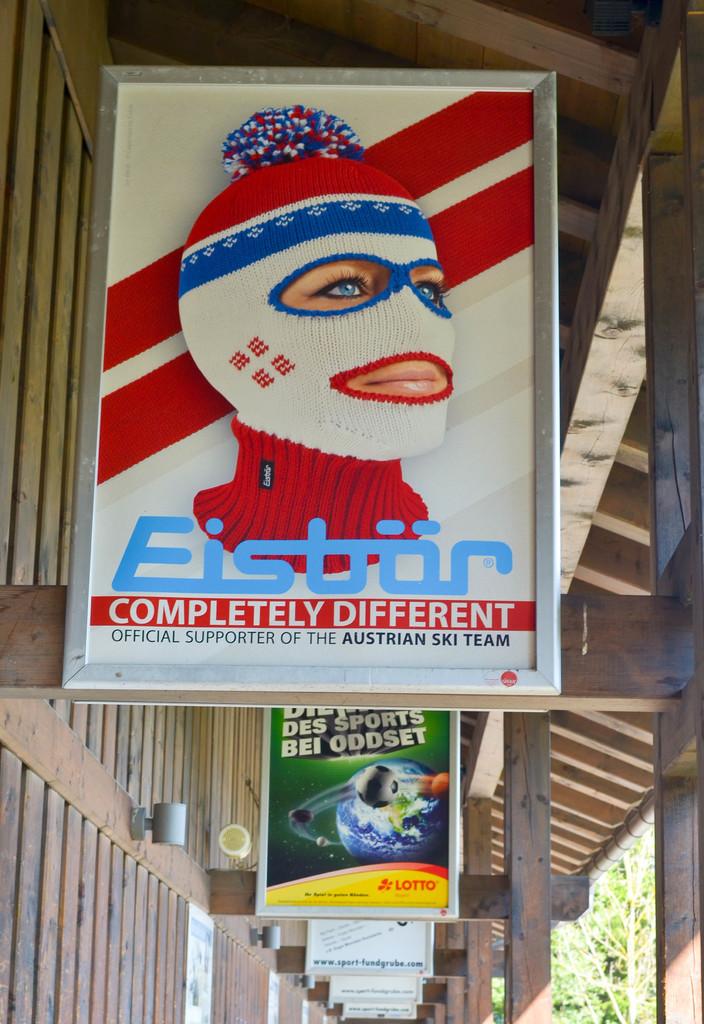Where is a eistrar store located?
Give a very brief answer. Austria. What's the tagline for eistrat?
Ensure brevity in your answer.  Completely different. 